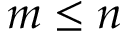Convert formula to latex. <formula><loc_0><loc_0><loc_500><loc_500>m \leq n</formula> 